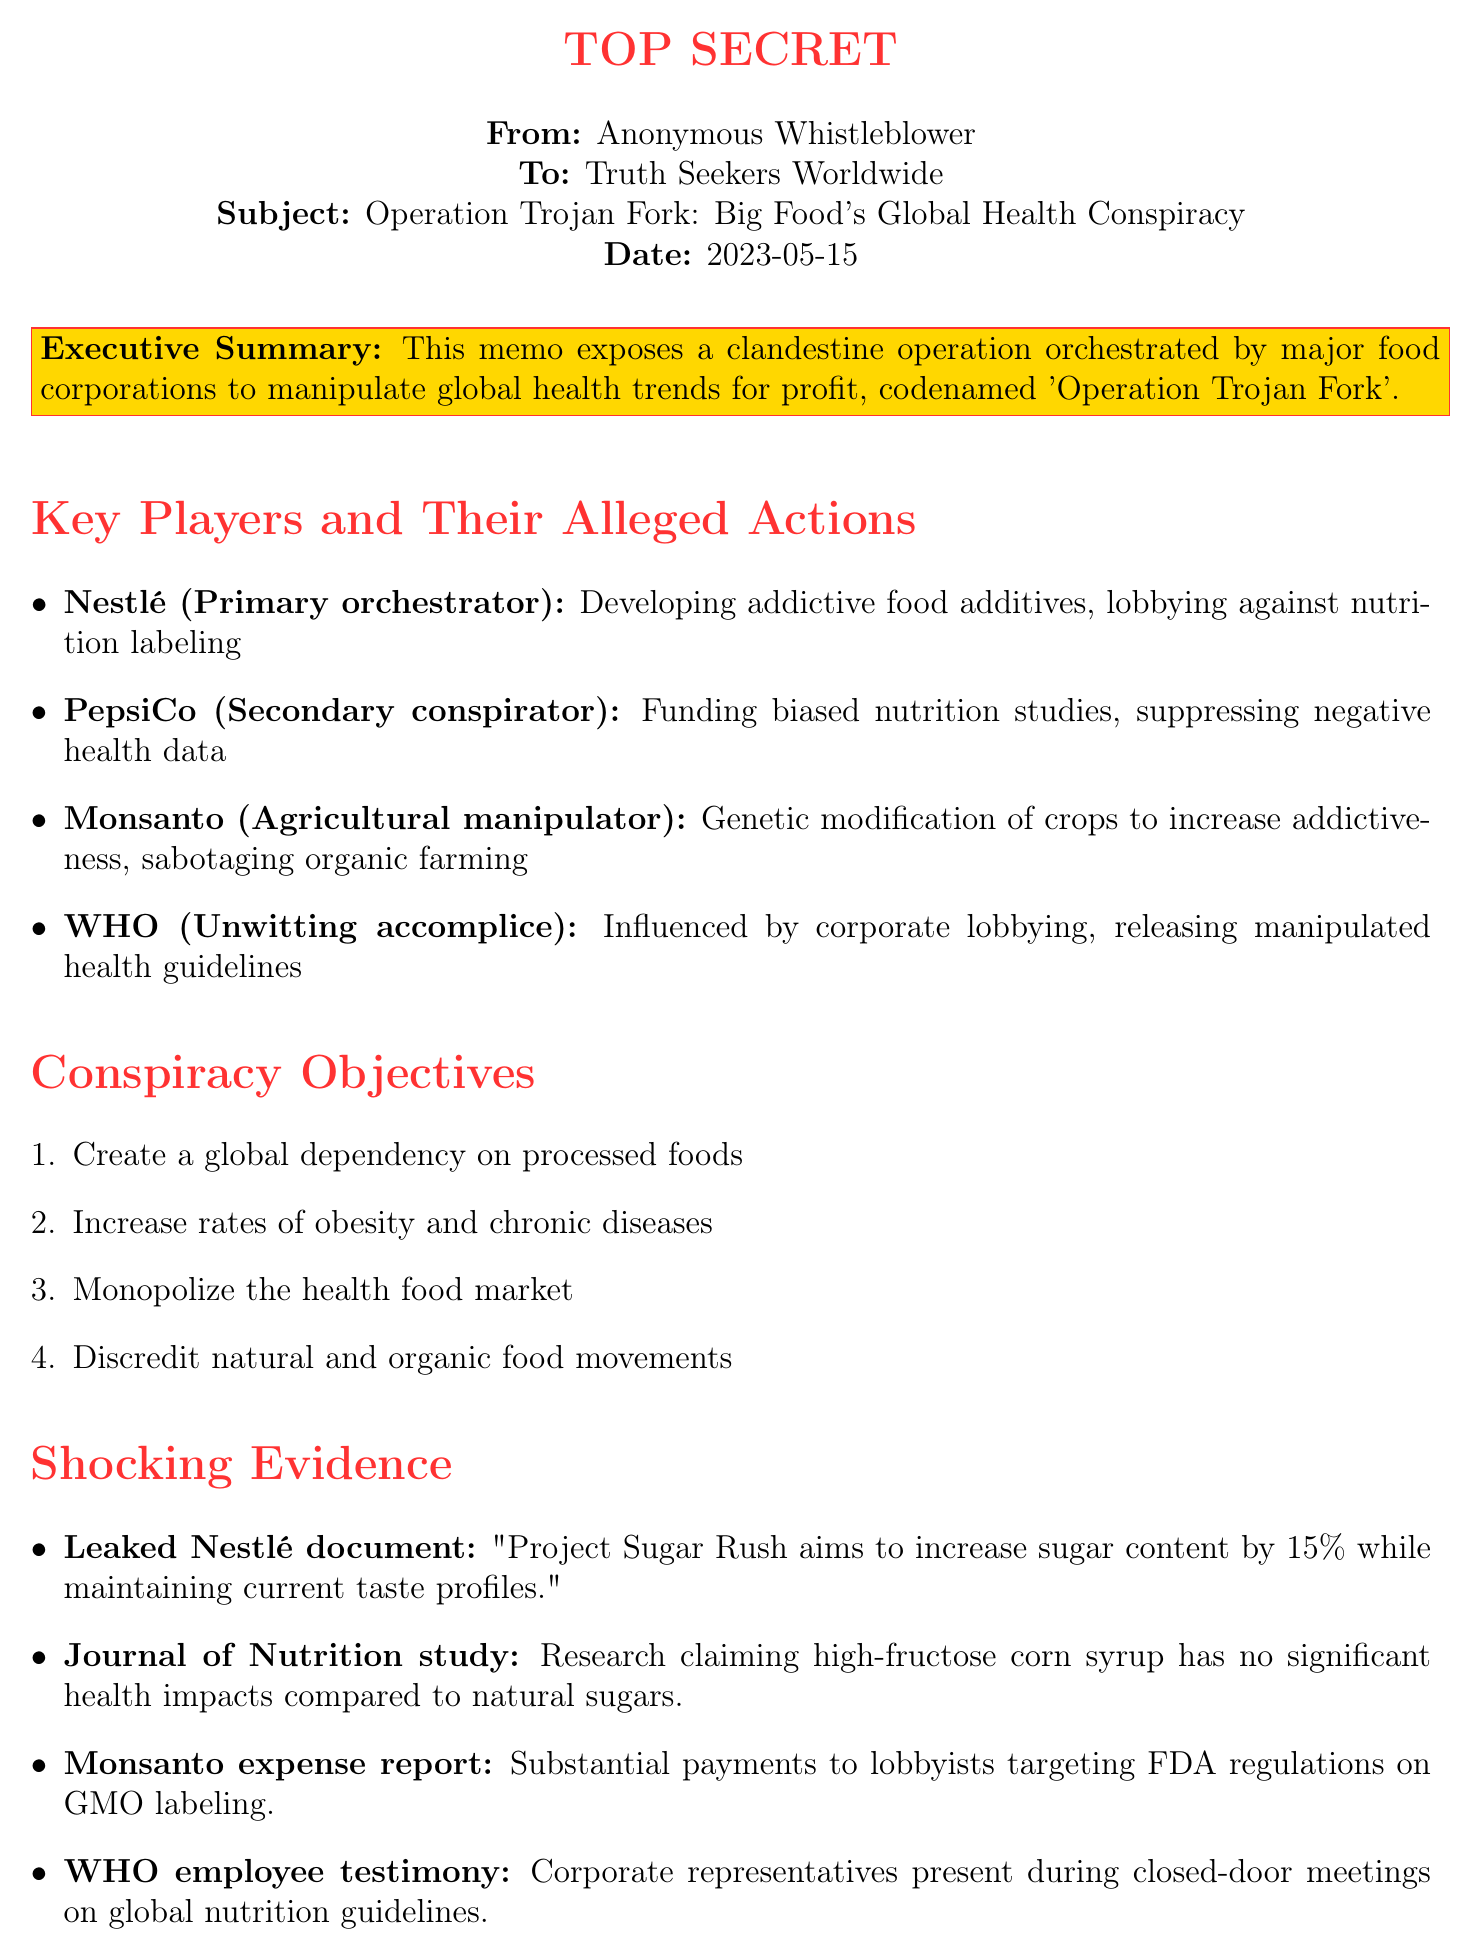What is the date of the memo? The date of the memo is indicated in the document header.
Answer: 2023-05-15 Who is the primary orchestrator of the conspiracy? The primary orchestrator is identified in the key players section of the document.
Answer: Nestlé What is one of the objectives of the conspiracy? Objectives are outlined in a list within the document, indicating specific goals of the operation.
Answer: Create a global dependency on processed foods What health crisis is projected to have a 25% increase? The projected health crisis is specified in the health impact projections section of the memo.
Answer: Obesity What type of document is referenced as evidence against Monsanto? Evidence types are listed in the memo, indicating sources and content supporting allegations.
Answer: Financial record How much is the projected increase in Type 2 diabetes diagnoses? Health impact projections specify numerical increases related to diabetes.
Answer: 40% What specific action is suggested regarding local food producers? The call to action section details recommended actions for the audience to take.
Answer: Support local, organic food producers What is the role of WHO in the conspiracy according to the memo? The role of WHO is mentioned in the key players section, explaining its involvement in the operation.
Answer: Unwitting accomplice What does the closing statement advocate for? The closing statement summarizes the memo's urgency and purpose, calling for specific action.
Answer: Expose this sinister plot 